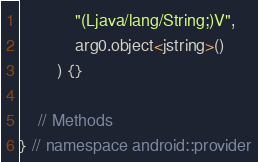Convert code to text. <code><loc_0><loc_0><loc_500><loc_500><_C++_>			"(Ljava/lang/String;)V",
			arg0.object<jstring>()
		) {}
	
	// Methods
} // namespace android::provider

</code> 